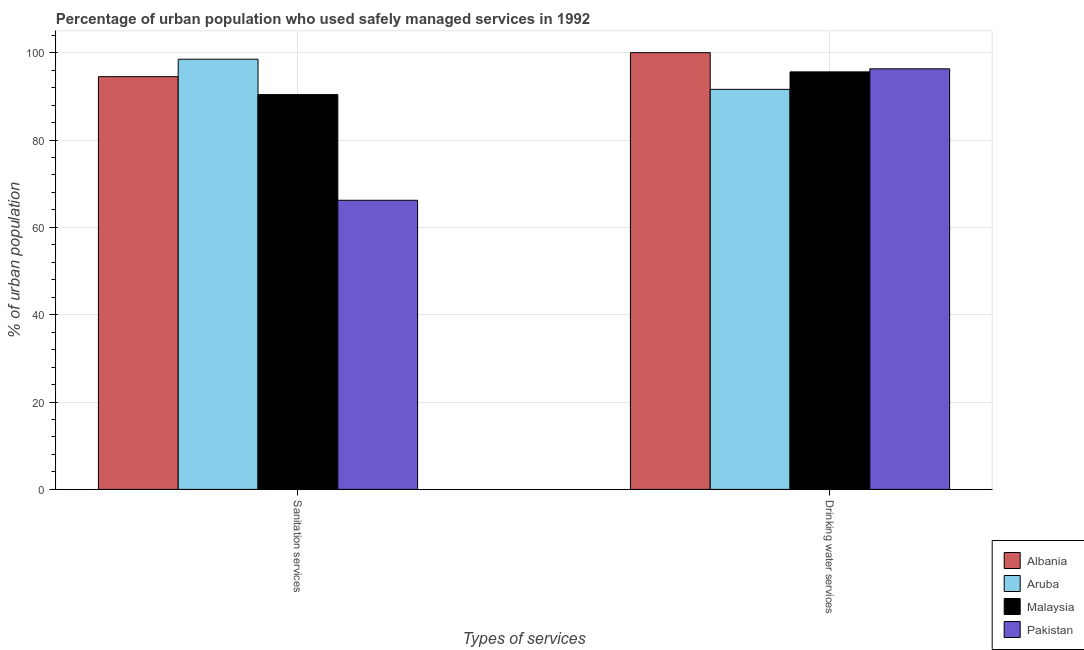How many different coloured bars are there?
Offer a very short reply. 4. How many groups of bars are there?
Provide a short and direct response. 2. Are the number of bars per tick equal to the number of legend labels?
Give a very brief answer. Yes. How many bars are there on the 1st tick from the right?
Offer a terse response. 4. What is the label of the 1st group of bars from the left?
Offer a very short reply. Sanitation services. What is the percentage of urban population who used drinking water services in Malaysia?
Your response must be concise. 95.6. Across all countries, what is the minimum percentage of urban population who used drinking water services?
Your response must be concise. 91.6. In which country was the percentage of urban population who used sanitation services maximum?
Give a very brief answer. Aruba. In which country was the percentage of urban population who used drinking water services minimum?
Your response must be concise. Aruba. What is the total percentage of urban population who used sanitation services in the graph?
Your answer should be compact. 349.6. What is the difference between the percentage of urban population who used sanitation services in Aruba and that in Pakistan?
Provide a succinct answer. 32.3. What is the difference between the percentage of urban population who used drinking water services in Albania and the percentage of urban population who used sanitation services in Pakistan?
Offer a very short reply. 33.8. What is the average percentage of urban population who used drinking water services per country?
Ensure brevity in your answer.  95.88. What is the difference between the percentage of urban population who used sanitation services and percentage of urban population who used drinking water services in Aruba?
Make the answer very short. 6.9. What is the ratio of the percentage of urban population who used sanitation services in Albania to that in Malaysia?
Your answer should be very brief. 1.05. Is the percentage of urban population who used sanitation services in Malaysia less than that in Aruba?
Provide a short and direct response. Yes. In how many countries, is the percentage of urban population who used sanitation services greater than the average percentage of urban population who used sanitation services taken over all countries?
Ensure brevity in your answer.  3. What does the 2nd bar from the left in Drinking water services represents?
Offer a very short reply. Aruba. What does the 2nd bar from the right in Drinking water services represents?
Give a very brief answer. Malaysia. How many countries are there in the graph?
Your answer should be very brief. 4. What is the difference between two consecutive major ticks on the Y-axis?
Your answer should be very brief. 20. Does the graph contain grids?
Give a very brief answer. Yes. How are the legend labels stacked?
Keep it short and to the point. Vertical. What is the title of the graph?
Give a very brief answer. Percentage of urban population who used safely managed services in 1992. What is the label or title of the X-axis?
Ensure brevity in your answer.  Types of services. What is the label or title of the Y-axis?
Your answer should be compact. % of urban population. What is the % of urban population of Albania in Sanitation services?
Keep it short and to the point. 94.5. What is the % of urban population of Aruba in Sanitation services?
Your answer should be compact. 98.5. What is the % of urban population of Malaysia in Sanitation services?
Your response must be concise. 90.4. What is the % of urban population of Pakistan in Sanitation services?
Your response must be concise. 66.2. What is the % of urban population in Albania in Drinking water services?
Your answer should be very brief. 100. What is the % of urban population of Aruba in Drinking water services?
Offer a terse response. 91.6. What is the % of urban population in Malaysia in Drinking water services?
Keep it short and to the point. 95.6. What is the % of urban population in Pakistan in Drinking water services?
Your answer should be very brief. 96.3. Across all Types of services, what is the maximum % of urban population in Aruba?
Keep it short and to the point. 98.5. Across all Types of services, what is the maximum % of urban population of Malaysia?
Keep it short and to the point. 95.6. Across all Types of services, what is the maximum % of urban population of Pakistan?
Provide a succinct answer. 96.3. Across all Types of services, what is the minimum % of urban population of Albania?
Offer a terse response. 94.5. Across all Types of services, what is the minimum % of urban population in Aruba?
Ensure brevity in your answer.  91.6. Across all Types of services, what is the minimum % of urban population in Malaysia?
Provide a succinct answer. 90.4. Across all Types of services, what is the minimum % of urban population in Pakistan?
Offer a very short reply. 66.2. What is the total % of urban population of Albania in the graph?
Keep it short and to the point. 194.5. What is the total % of urban population of Aruba in the graph?
Make the answer very short. 190.1. What is the total % of urban population of Malaysia in the graph?
Provide a succinct answer. 186. What is the total % of urban population in Pakistan in the graph?
Keep it short and to the point. 162.5. What is the difference between the % of urban population in Aruba in Sanitation services and that in Drinking water services?
Keep it short and to the point. 6.9. What is the difference between the % of urban population in Pakistan in Sanitation services and that in Drinking water services?
Ensure brevity in your answer.  -30.1. What is the difference between the % of urban population in Albania in Sanitation services and the % of urban population in Aruba in Drinking water services?
Provide a succinct answer. 2.9. What is the difference between the % of urban population in Albania in Sanitation services and the % of urban population in Pakistan in Drinking water services?
Make the answer very short. -1.8. What is the difference between the % of urban population of Aruba in Sanitation services and the % of urban population of Malaysia in Drinking water services?
Keep it short and to the point. 2.9. What is the difference between the % of urban population of Aruba in Sanitation services and the % of urban population of Pakistan in Drinking water services?
Make the answer very short. 2.2. What is the difference between the % of urban population in Malaysia in Sanitation services and the % of urban population in Pakistan in Drinking water services?
Your answer should be very brief. -5.9. What is the average % of urban population of Albania per Types of services?
Offer a very short reply. 97.25. What is the average % of urban population in Aruba per Types of services?
Keep it short and to the point. 95.05. What is the average % of urban population in Malaysia per Types of services?
Offer a terse response. 93. What is the average % of urban population in Pakistan per Types of services?
Keep it short and to the point. 81.25. What is the difference between the % of urban population of Albania and % of urban population of Malaysia in Sanitation services?
Offer a very short reply. 4.1. What is the difference between the % of urban population of Albania and % of urban population of Pakistan in Sanitation services?
Your response must be concise. 28.3. What is the difference between the % of urban population of Aruba and % of urban population of Malaysia in Sanitation services?
Give a very brief answer. 8.1. What is the difference between the % of urban population in Aruba and % of urban population in Pakistan in Sanitation services?
Provide a short and direct response. 32.3. What is the difference between the % of urban population of Malaysia and % of urban population of Pakistan in Sanitation services?
Provide a short and direct response. 24.2. What is the difference between the % of urban population of Albania and % of urban population of Aruba in Drinking water services?
Make the answer very short. 8.4. What is the difference between the % of urban population in Albania and % of urban population in Malaysia in Drinking water services?
Offer a terse response. 4.4. What is the ratio of the % of urban population in Albania in Sanitation services to that in Drinking water services?
Provide a succinct answer. 0.94. What is the ratio of the % of urban population in Aruba in Sanitation services to that in Drinking water services?
Offer a terse response. 1.08. What is the ratio of the % of urban population in Malaysia in Sanitation services to that in Drinking water services?
Offer a very short reply. 0.95. What is the ratio of the % of urban population of Pakistan in Sanitation services to that in Drinking water services?
Ensure brevity in your answer.  0.69. What is the difference between the highest and the second highest % of urban population of Albania?
Offer a terse response. 5.5. What is the difference between the highest and the second highest % of urban population in Aruba?
Your answer should be compact. 6.9. What is the difference between the highest and the second highest % of urban population of Pakistan?
Give a very brief answer. 30.1. What is the difference between the highest and the lowest % of urban population in Albania?
Make the answer very short. 5.5. What is the difference between the highest and the lowest % of urban population in Aruba?
Your answer should be very brief. 6.9. What is the difference between the highest and the lowest % of urban population of Pakistan?
Offer a terse response. 30.1. 